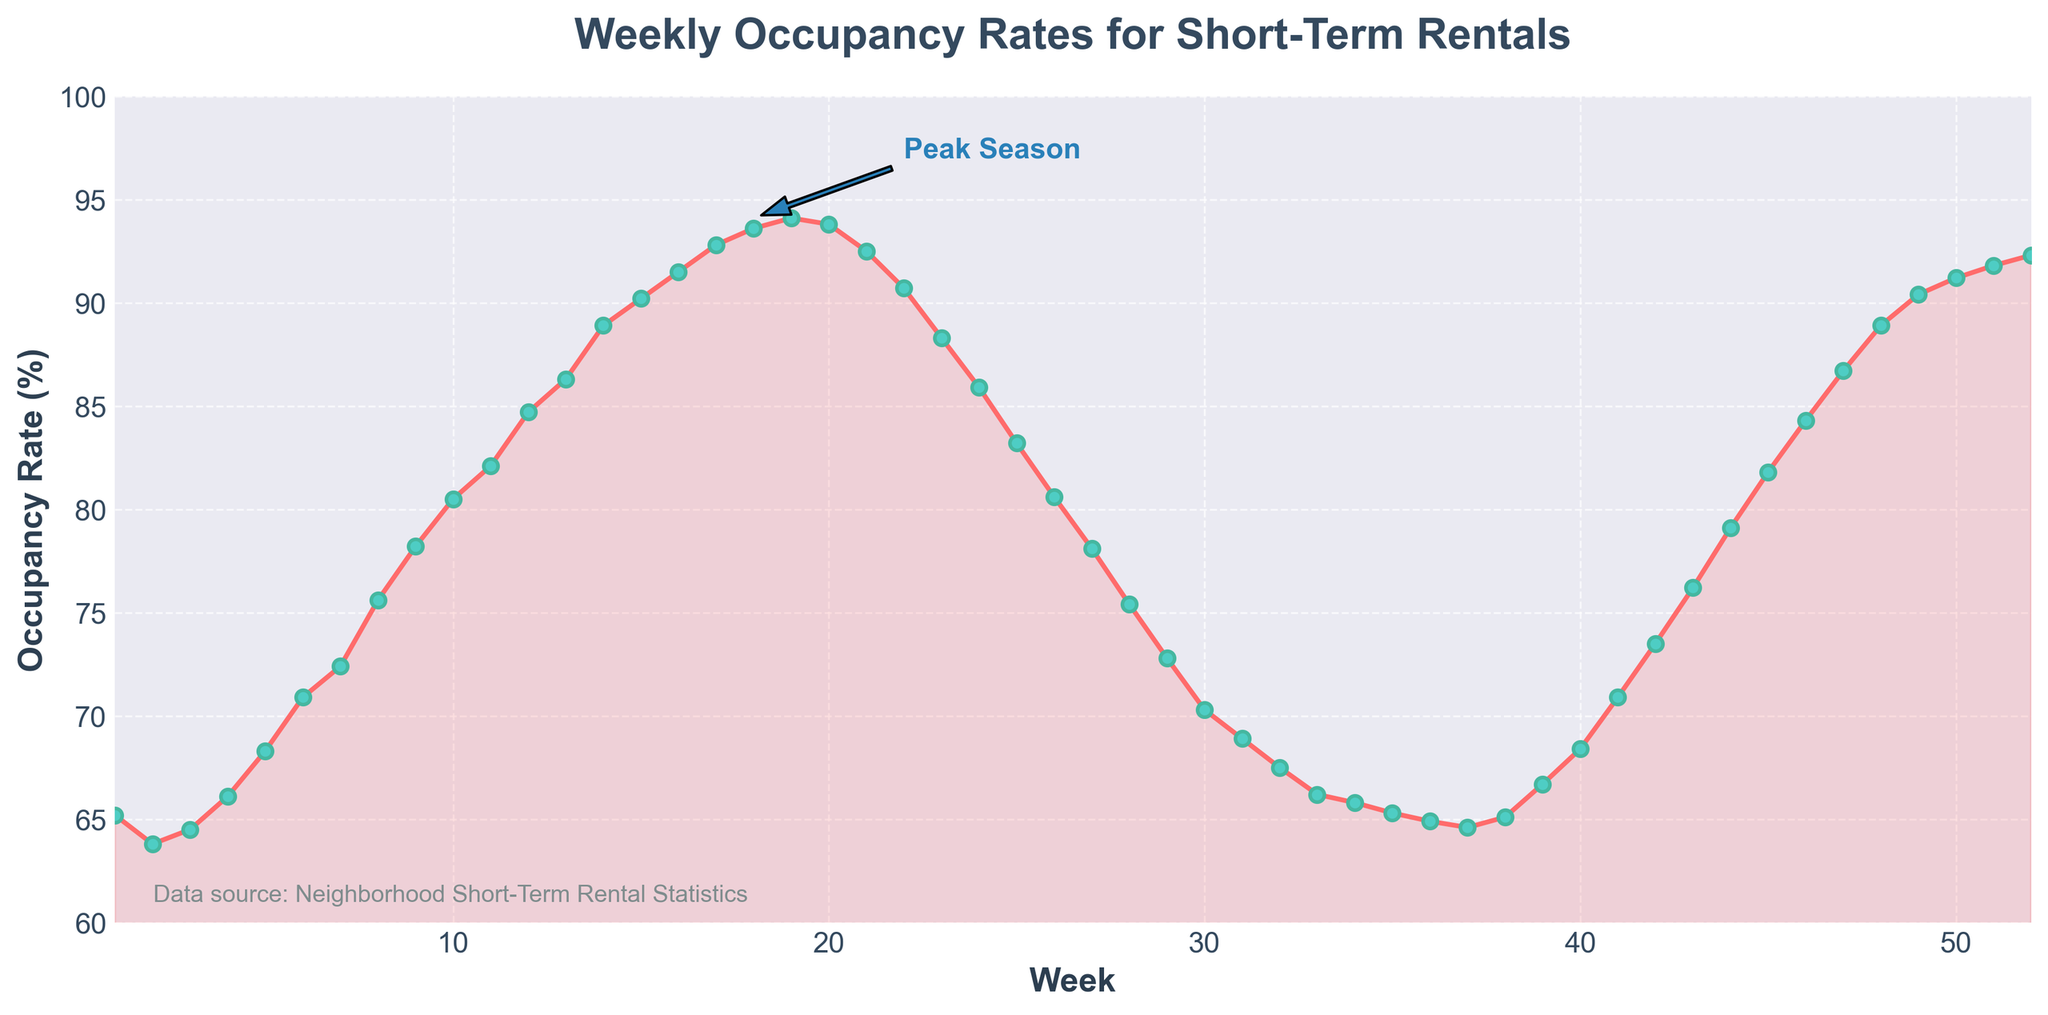When is the occupancy rate at its highest point? The highest occupancy rate is noted at the peak of the plotted line on the chart. This occurs at Week 19 with a rate of 94.1%.
Answer: Week 19 At which week does the occupancy rate first exceed 90%? Look at the point where the plotted line first crosses the 90% marker. This is observed at Week 15 with an occupancy rate of 90.2%.
Answer: Week 15 By how much did the occupancy rate drop from Week 19 to Week 22? The occupancy rate at Week 19 is 94.1%, and at Week 22, it is 90.7%. Subtracting the latter from the former gives 94.1% - 90.7% = 3.4%.
Answer: 3.4% What is the average occupancy rate over the entire year? Sum all the weekly occupancy rates, then divide by the number of weeks (52). The sum is 3910.3, so the average is 3910.3 / 52 ≈ 75.2%.
Answer: 75.2% How many times does the occupancy rate exceed 80% throughout the year? Examining the chart, the occupancy rate exceeds 80% in 19 weeks, specifically Weeks 10 to Week 22, and Week 44 to Week 52.
Answer: 19 Compare the occupancy rates of Week 1 and Week 52. Which one is higher and by how much? Week 1 has an occupancy rate of 65.2% and Week 52 has 92.3%. Subtract Week 1's rate from Week 52's: 92.3% - 65.2% = 27.1%.
Answer: Week 52 by 27.1% What is the overall trend in occupancy rates from Week 1 to Week 18? The plotted line from Week 1 to Week 18 shows a general upward trend, rising from 65.2% to 93.6%.
Answer: Upward trend Identify the weeks during which the occupancy rate begins to consistently rise after a decline. After the decline observed until Week 36 at 64.9%, the occupancy rate begins to consistently rise starting from Week 37 at 64.6%.
Answer: Week 37 What is the difference in occupancy rates between Week 25 and Week 42? Week 25 has an occupancy rate of 83.2%, while Week 42 has a rate of 73.5%. The difference is 83.2% - 73.5% = 9.7%.
Answer: 9.7% How many weeks does the occupancy rate stay above the 70% mark? Identify the weeks where occupancy is above 70%. The occupancy rate stays above 70% for 28 weeks in total.
Answer: 28 